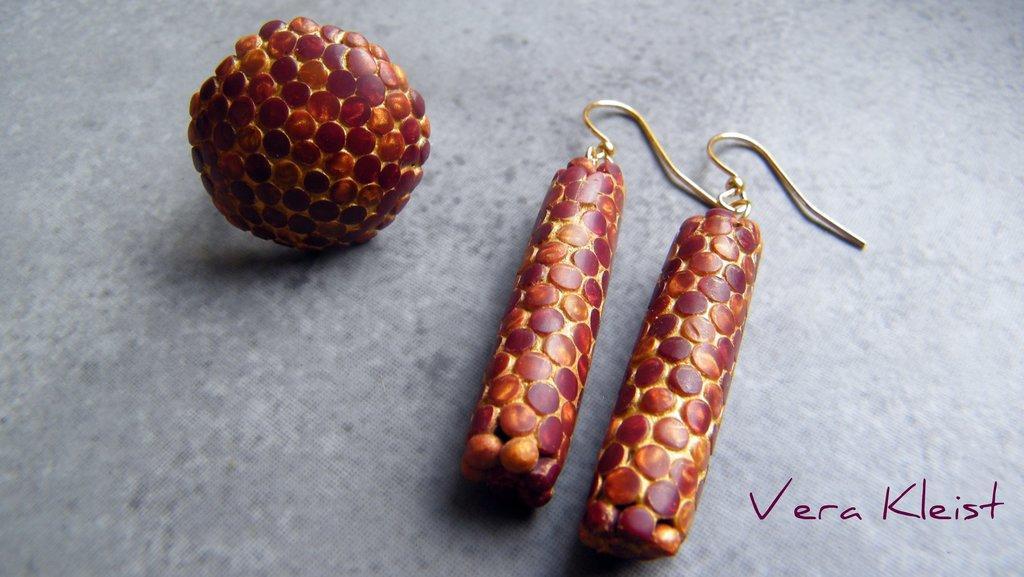In one or two sentences, can you explain what this image depicts? In this picture, it seems like earrings in the center and text at the bottom side. 